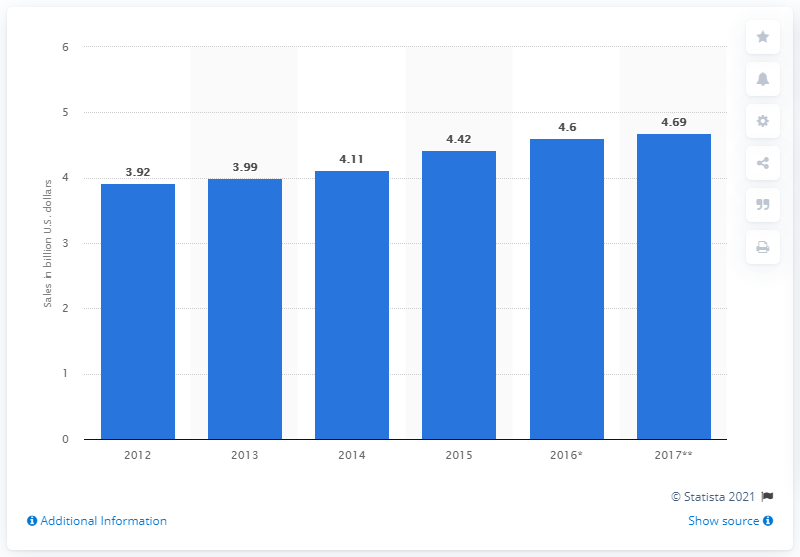Identify some key points in this picture. In 2014, the amount of dollars generated from home security solution sales in the United States was 4.11. 